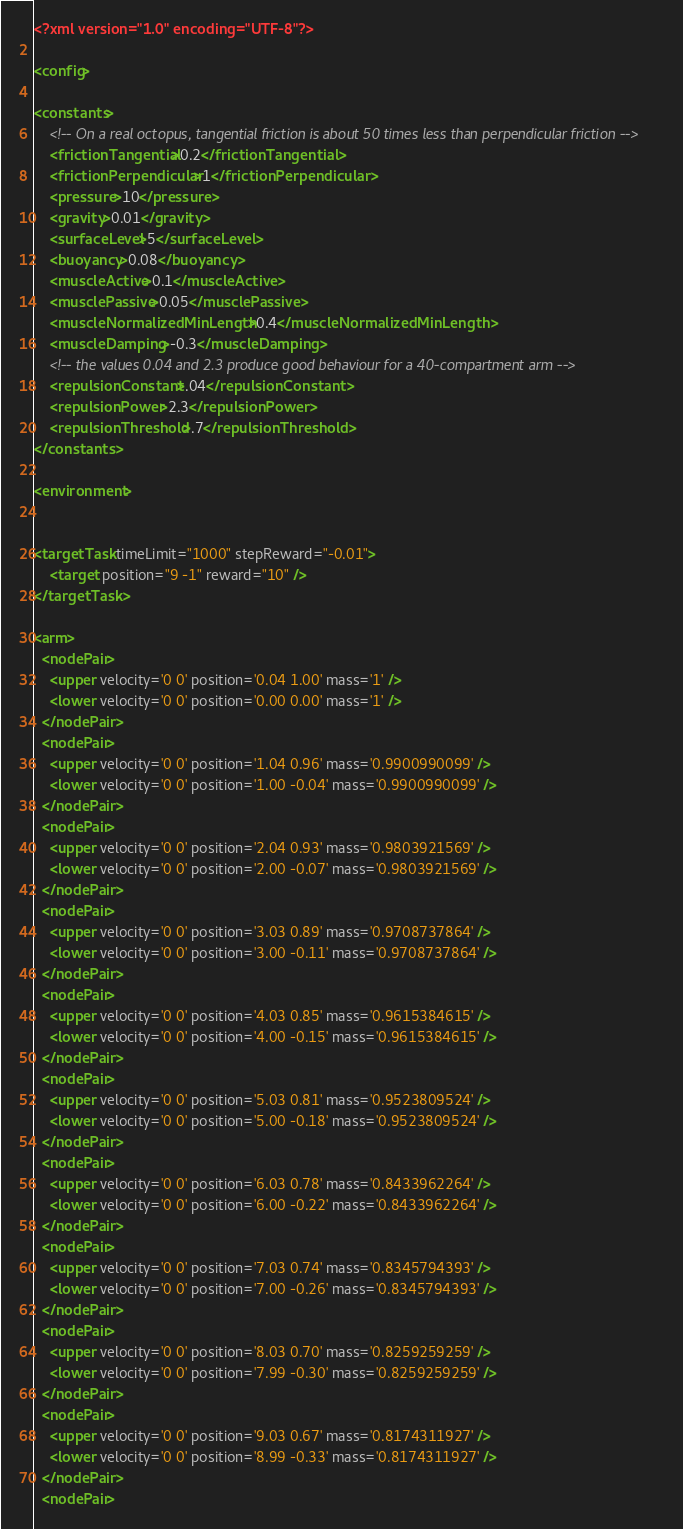Convert code to text. <code><loc_0><loc_0><loc_500><loc_500><_XML_><?xml version="1.0" encoding="UTF-8"?>

<config>

<constants>
    <!-- On a real octopus, tangential friction is about 50 times less than perpendicular friction -->
    <frictionTangential>0.2</frictionTangential>
    <frictionPerpendicular>1</frictionPerpendicular>
    <pressure>10</pressure>
    <gravity>0.01</gravity>
    <surfaceLevel>5</surfaceLevel>
    <buoyancy>0.08</buoyancy>
    <muscleActive>0.1</muscleActive>
    <musclePassive>0.05</musclePassive>
    <muscleNormalizedMinLength>0.4</muscleNormalizedMinLength>
    <muscleDamping>-0.3</muscleDamping>
    <!-- the values 0.04 and 2.3 produce good behaviour for a 40-compartment arm -->
    <repulsionConstant>.04</repulsionConstant> 
    <repulsionPower>2.3</repulsionPower>
    <repulsionThreshold>.7</repulsionThreshold>
</constants>

<environment>
    

<targetTask timeLimit="1000" stepReward="-0.01">
    <target position="9 -1" reward="10" />
</targetTask>

<arm>
  <nodePair>
    <upper velocity='0 0' position='0.04 1.00' mass='1' />
    <lower velocity='0 0' position='0.00 0.00' mass='1' />
  </nodePair>
  <nodePair>
    <upper velocity='0 0' position='1.04 0.96' mass='0.9900990099' />
    <lower velocity='0 0' position='1.00 -0.04' mass='0.9900990099' />
  </nodePair>
  <nodePair>
    <upper velocity='0 0' position='2.04 0.93' mass='0.9803921569' />
    <lower velocity='0 0' position='2.00 -0.07' mass='0.9803921569' />
  </nodePair>
  <nodePair>
    <upper velocity='0 0' position='3.03 0.89' mass='0.9708737864' />
    <lower velocity='0 0' position='3.00 -0.11' mass='0.9708737864' />
  </nodePair>
  <nodePair>
    <upper velocity='0 0' position='4.03 0.85' mass='0.9615384615' />
    <lower velocity='0 0' position='4.00 -0.15' mass='0.9615384615' />
  </nodePair>
  <nodePair>
    <upper velocity='0 0' position='5.03 0.81' mass='0.9523809524' />
    <lower velocity='0 0' position='5.00 -0.18' mass='0.9523809524' />
  </nodePair>
  <nodePair>
    <upper velocity='0 0' position='6.03 0.78' mass='0.8433962264' />
    <lower velocity='0 0' position='6.00 -0.22' mass='0.8433962264' />
  </nodePair>
  <nodePair>
    <upper velocity='0 0' position='7.03 0.74' mass='0.8345794393' />
    <lower velocity='0 0' position='7.00 -0.26' mass='0.8345794393' />
  </nodePair>
  <nodePair>
    <upper velocity='0 0' position='8.03 0.70' mass='0.8259259259' />
    <lower velocity='0 0' position='7.99 -0.30' mass='0.8259259259' />
  </nodePair>
  <nodePair>
    <upper velocity='0 0' position='9.03 0.67' mass='0.8174311927' />
    <lower velocity='0 0' position='8.99 -0.33' mass='0.8174311927' />
  </nodePair>
  <nodePair></code> 